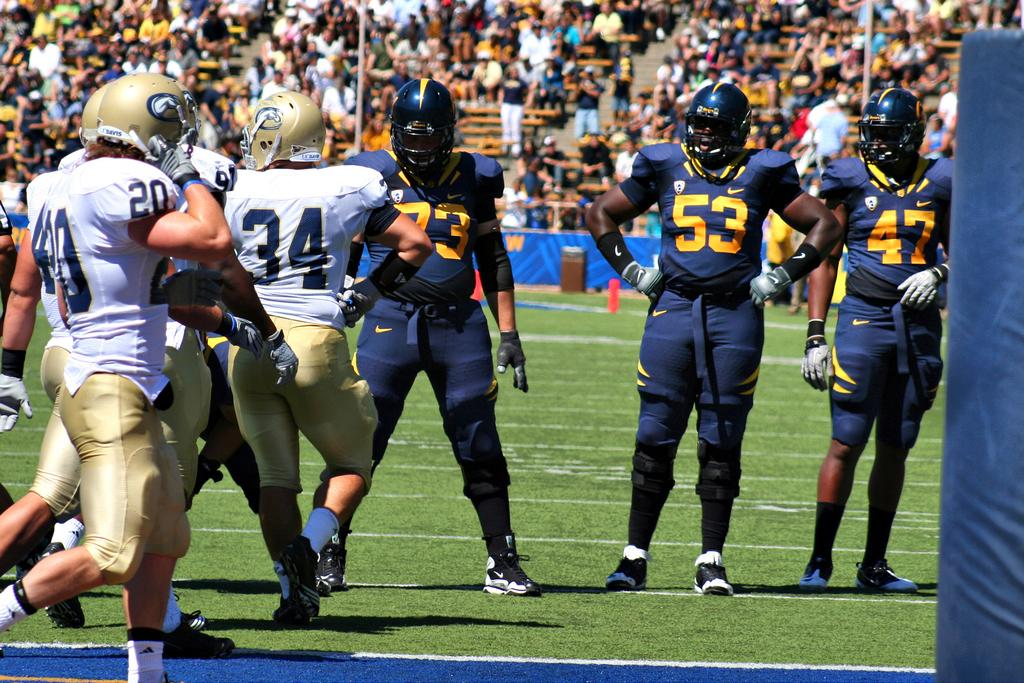How many people are in the image? There are people in the image, but the exact number is not specified. What are some people wearing in the image? Some people are wearing helmets in the image. What type of terrain is visible in the image? There is grass in the image, suggesting a natural outdoor setting. What can be seen hanging or displayed in the image? There is a banner in the image. What type of furniture is present in the image? There are chairs in the image. What architectural feature is visible in the image? There are stairs in the image. What type of engine can be seen powering the cattle in the image? There are no cattle or engines present in the image. 